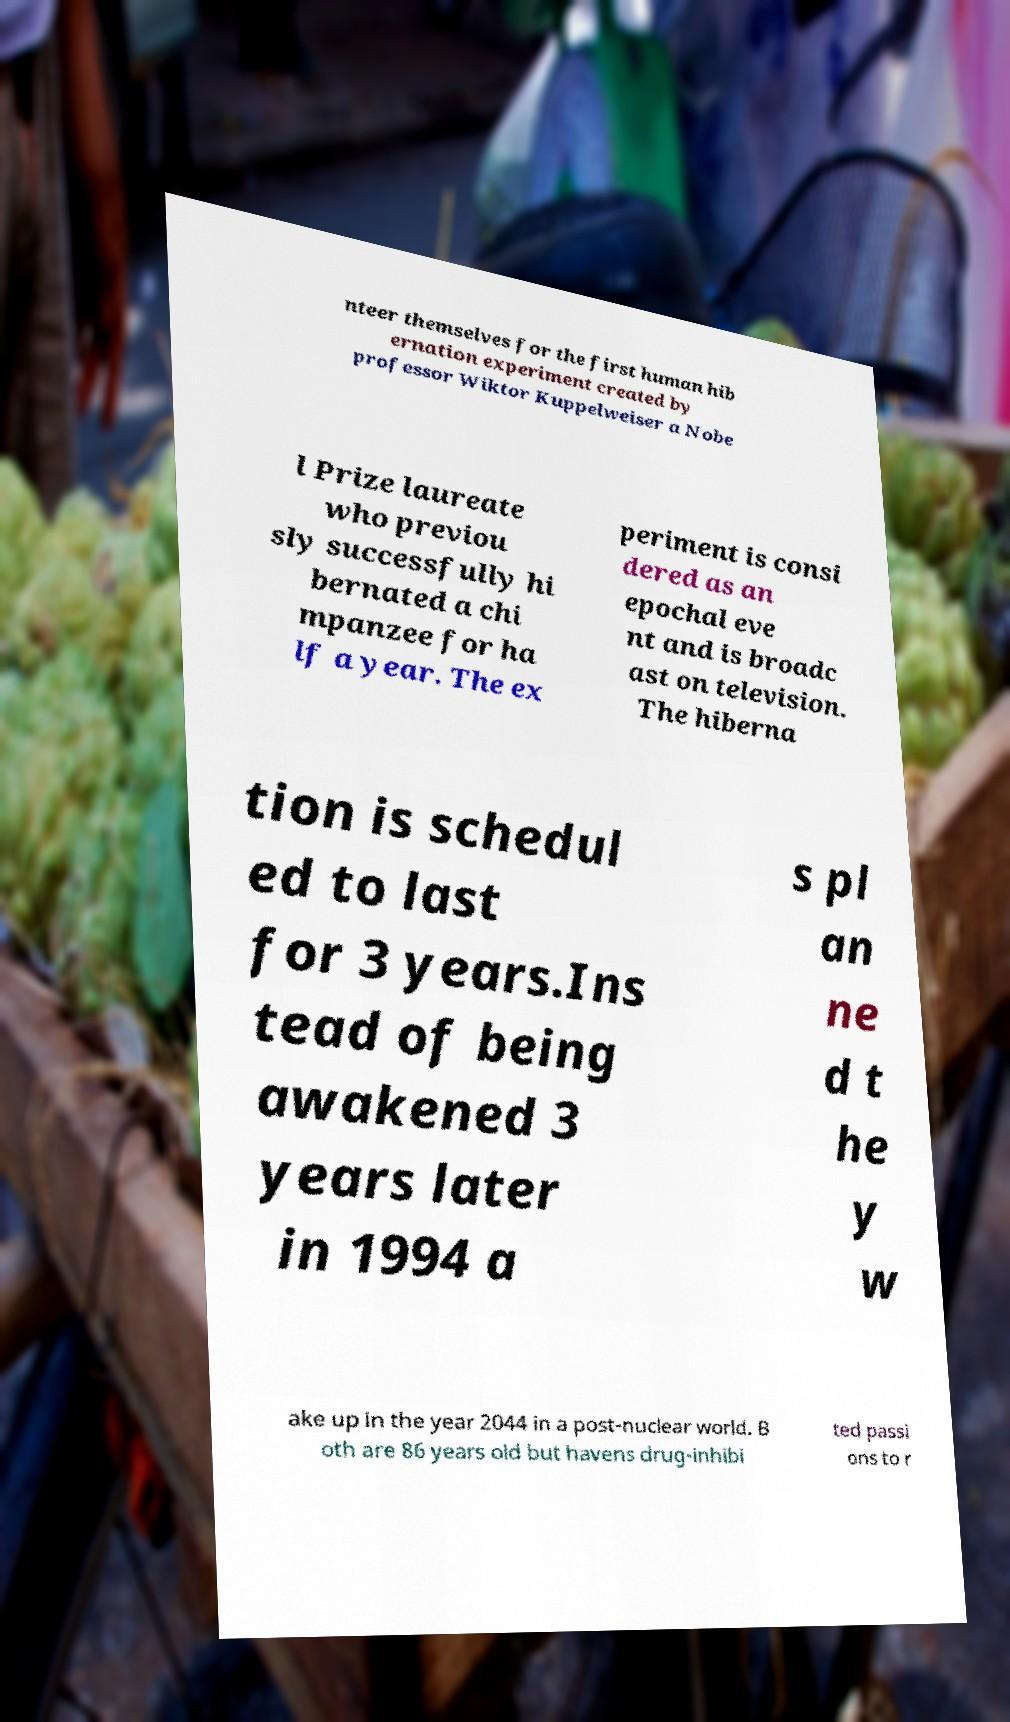I need the written content from this picture converted into text. Can you do that? nteer themselves for the first human hib ernation experiment created by professor Wiktor Kuppelweiser a Nobe l Prize laureate who previou sly successfully hi bernated a chi mpanzee for ha lf a year. The ex periment is consi dered as an epochal eve nt and is broadc ast on television. The hiberna tion is schedul ed to last for 3 years.Ins tead of being awakened 3 years later in 1994 a s pl an ne d t he y w ake up in the year 2044 in a post-nuclear world. B oth are 86 years old but havens drug-inhibi ted passi ons to r 